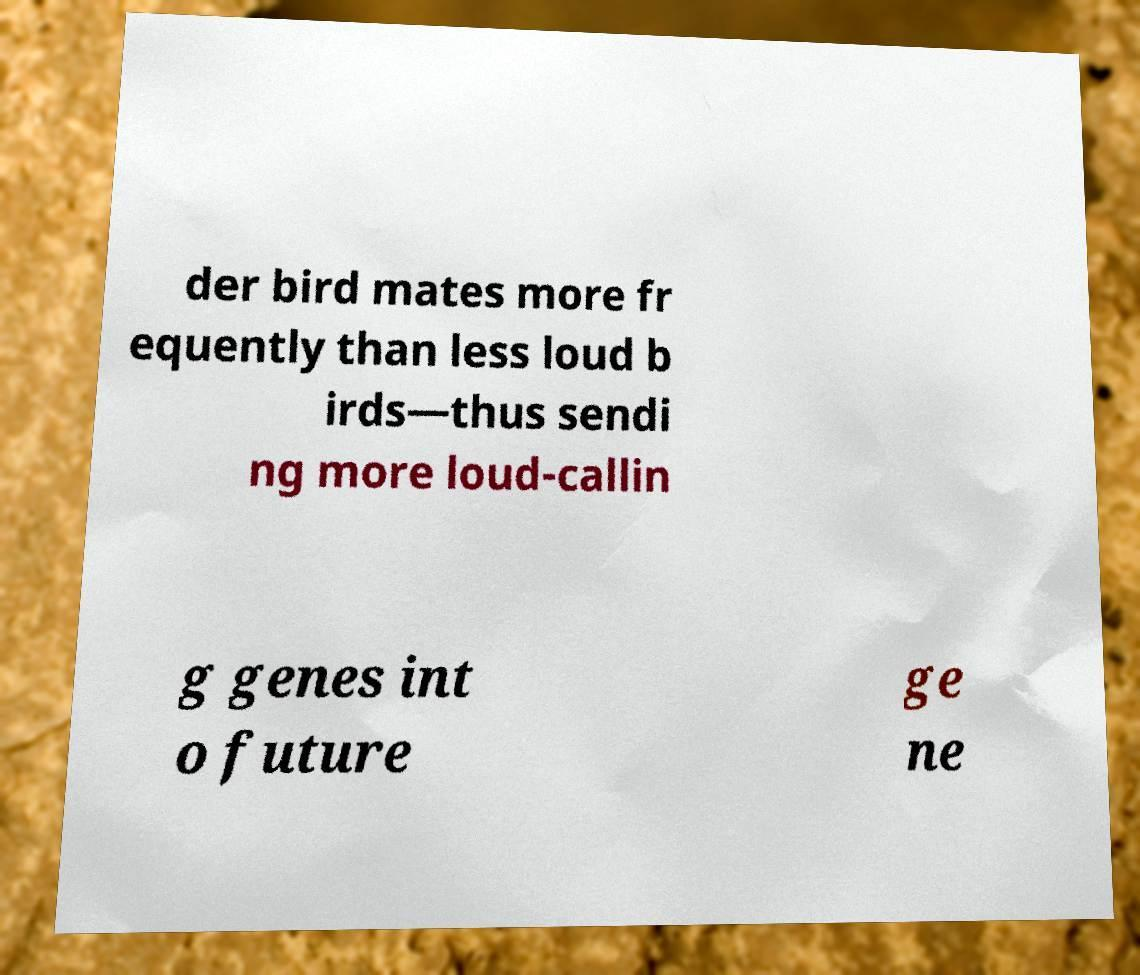Please read and relay the text visible in this image. What does it say? der bird mates more fr equently than less loud b irds—thus sendi ng more loud-callin g genes int o future ge ne 